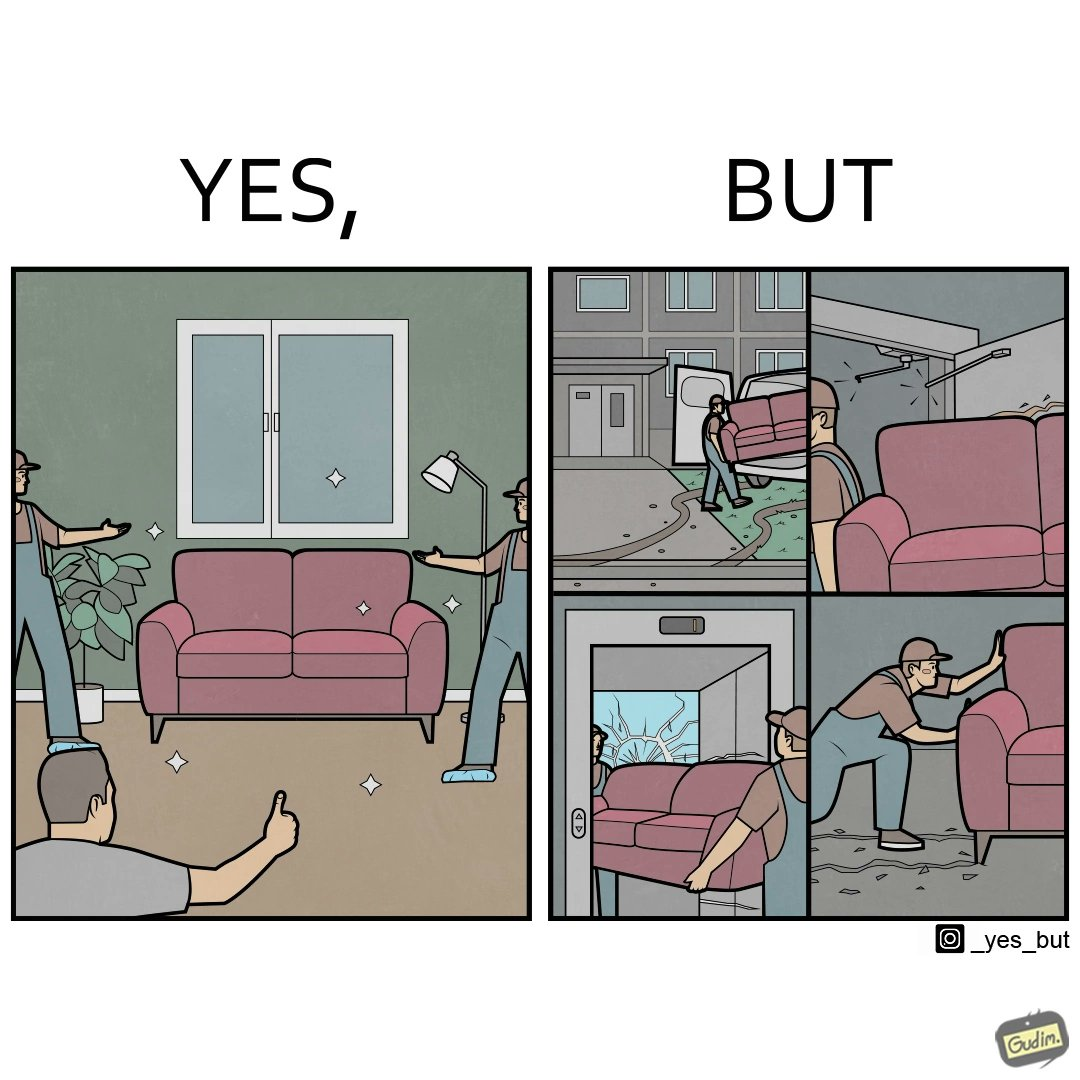Describe the satirical element in this image. The images are funny since they show how even though the hired movers achieve their task of moving in furniture, in the process, the cause damage to the whole house 